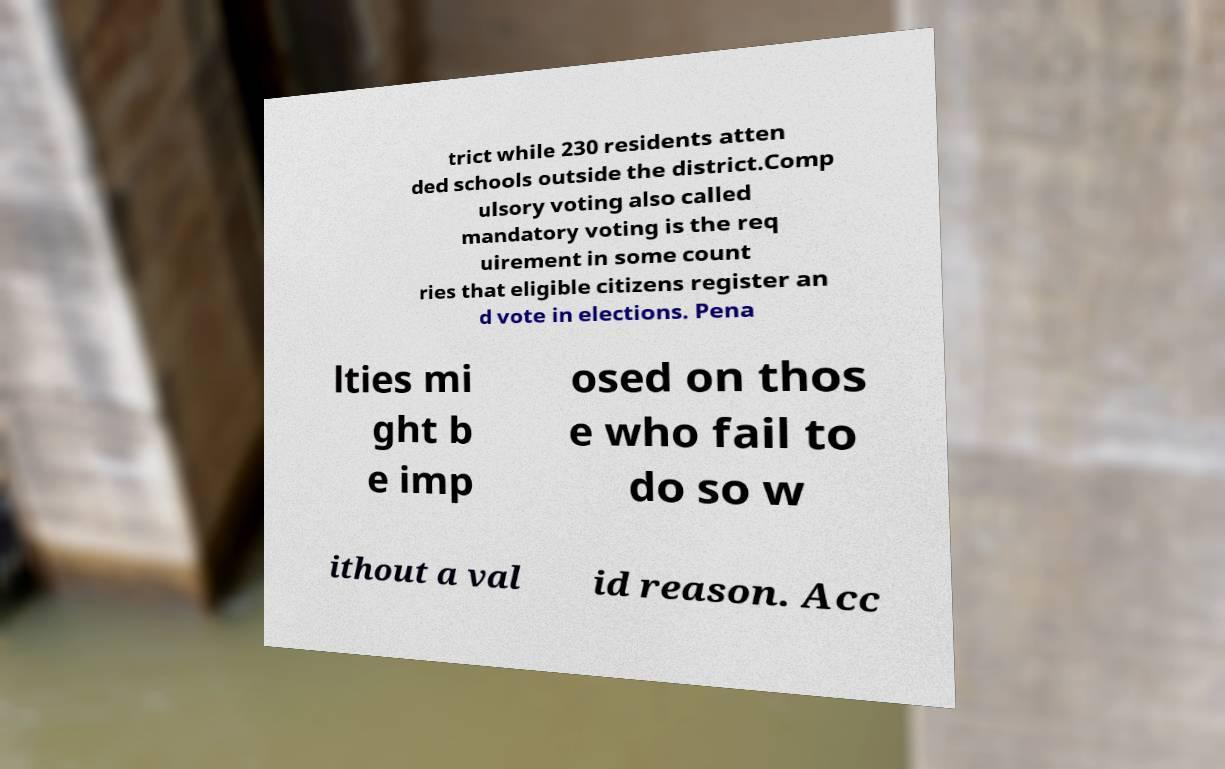For documentation purposes, I need the text within this image transcribed. Could you provide that? trict while 230 residents atten ded schools outside the district.Comp ulsory voting also called mandatory voting is the req uirement in some count ries that eligible citizens register an d vote in elections. Pena lties mi ght b e imp osed on thos e who fail to do so w ithout a val id reason. Acc 